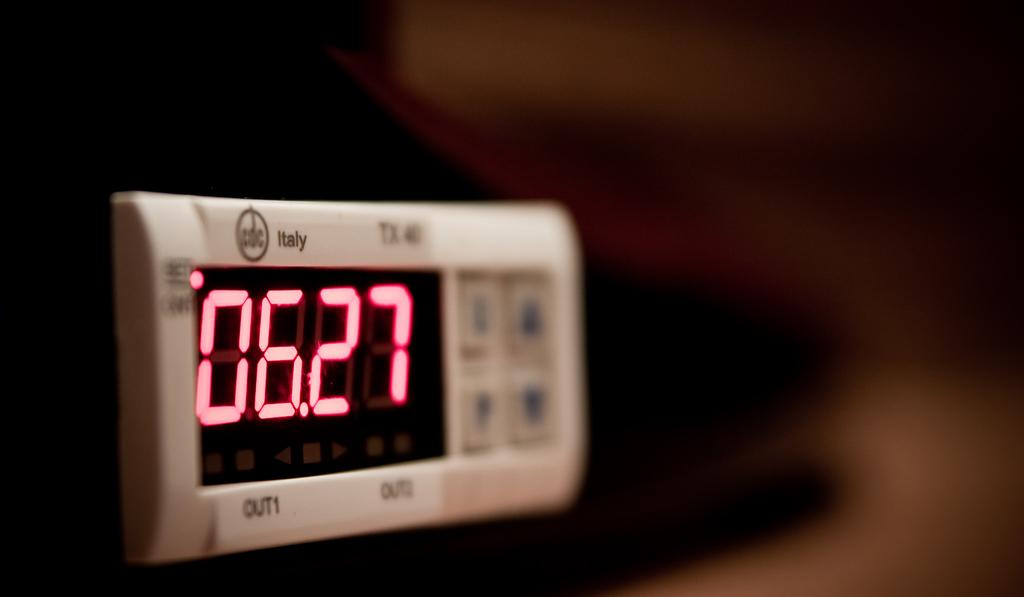<image>
Share a concise interpretation of the image provided. A digital screen from CDC Italy shows the number 06.27. 